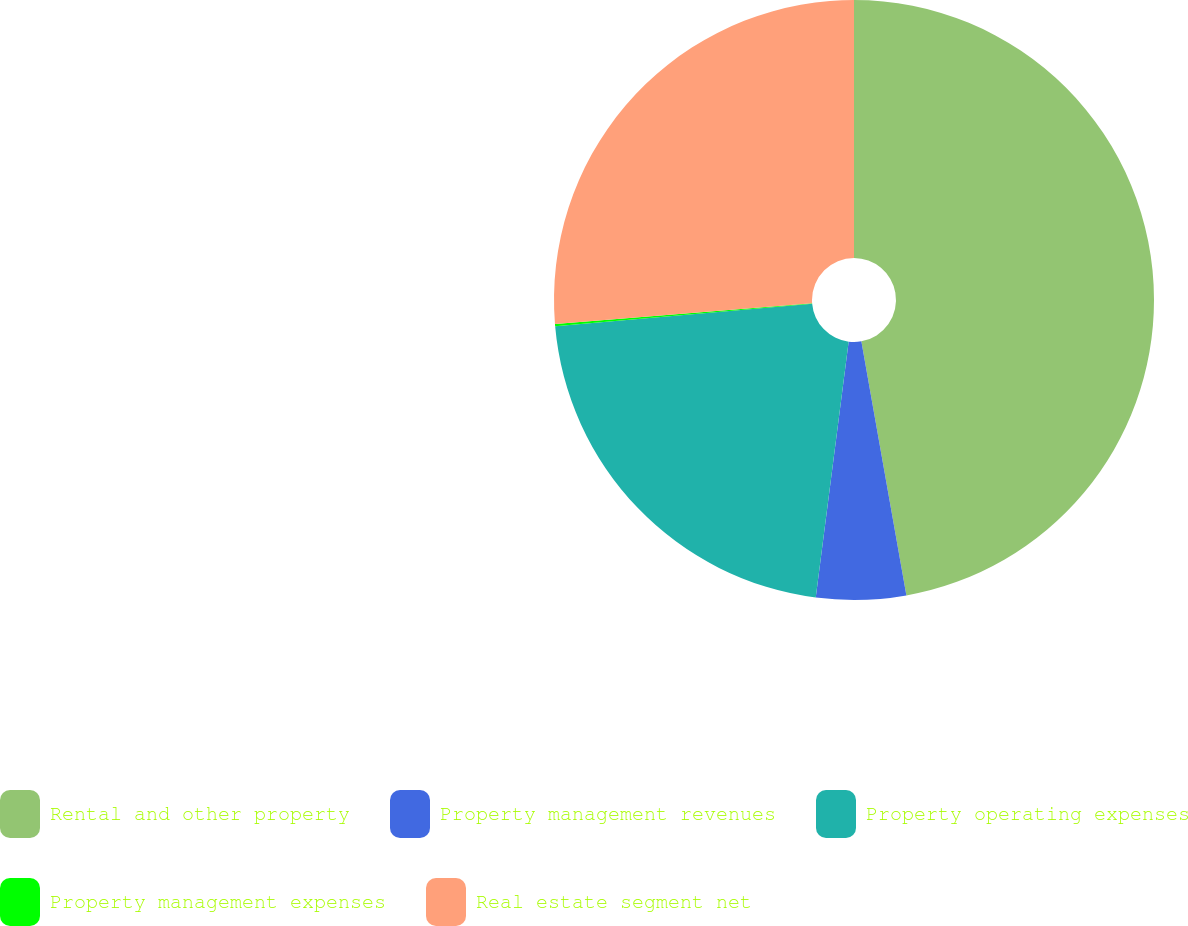Convert chart to OTSL. <chart><loc_0><loc_0><loc_500><loc_500><pie_chart><fcel>Rental and other property<fcel>Property management revenues<fcel>Property operating expenses<fcel>Property management expenses<fcel>Real estate segment net<nl><fcel>47.21%<fcel>4.83%<fcel>21.57%<fcel>0.12%<fcel>26.28%<nl></chart> 